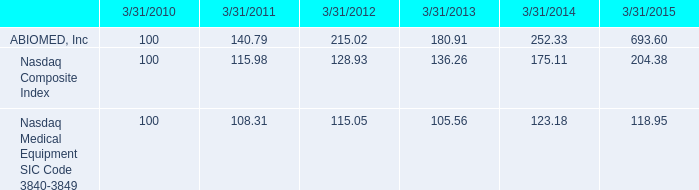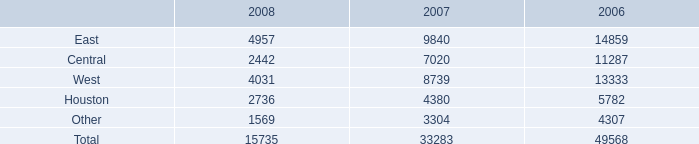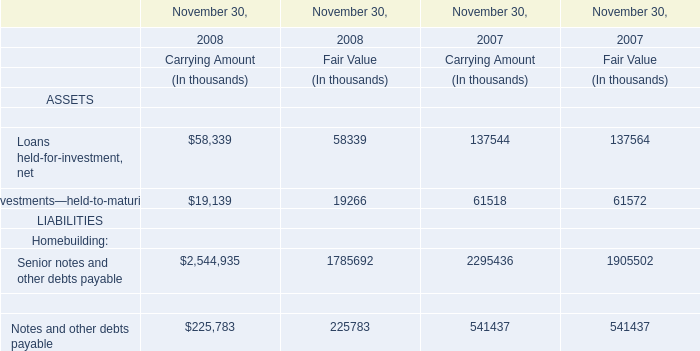what is the roi of an investment in nasdaq composite index from march 2010 to march 2013? 
Computations: ((136.26 - 100) / 100)
Answer: 0.3626. 